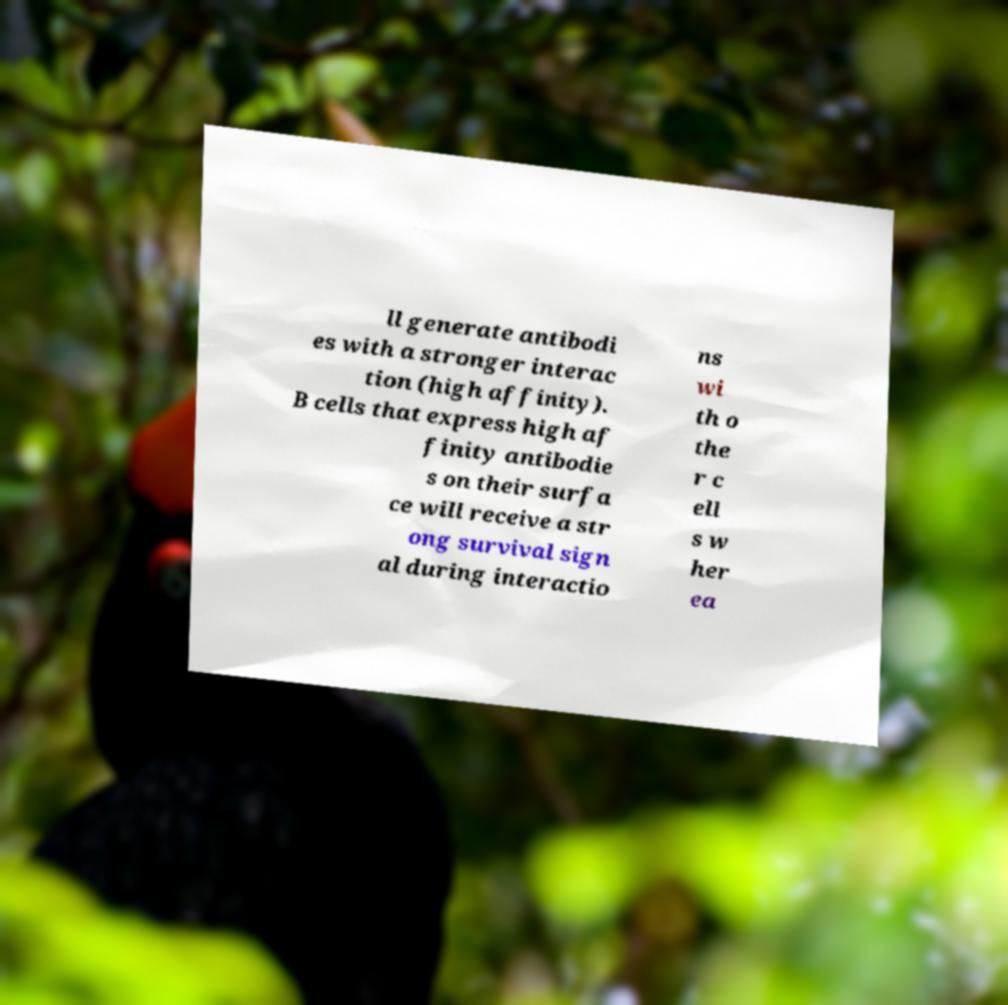There's text embedded in this image that I need extracted. Can you transcribe it verbatim? ll generate antibodi es with a stronger interac tion (high affinity). B cells that express high af finity antibodie s on their surfa ce will receive a str ong survival sign al during interactio ns wi th o the r c ell s w her ea 